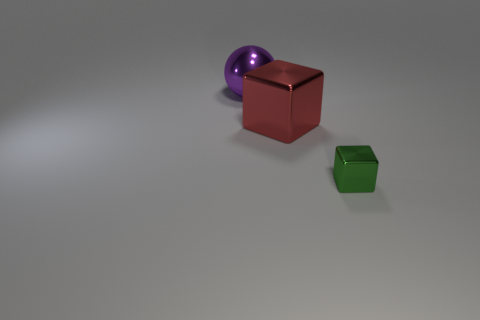Does the green thing have the same size as the red thing?
Provide a succinct answer. No. Are there an equal number of big things that are right of the purple object and green cubes in front of the tiny cube?
Ensure brevity in your answer.  No. Are there any tiny yellow rubber blocks?
Offer a very short reply. No. There is another metallic thing that is the same shape as the green shiny object; what size is it?
Make the answer very short. Large. How big is the metal block on the left side of the tiny green thing?
Provide a short and direct response. Large. Are there more red objects on the left side of the small object than tiny gray spheres?
Offer a terse response. Yes. There is a red thing; what shape is it?
Give a very brief answer. Cube. There is a object that is right of the large red metallic block; is its color the same as the large metal thing in front of the purple metallic object?
Your answer should be very brief. No. Is the large red object the same shape as the small green thing?
Offer a terse response. Yes. Is there anything else that is the same shape as the purple thing?
Ensure brevity in your answer.  No. 